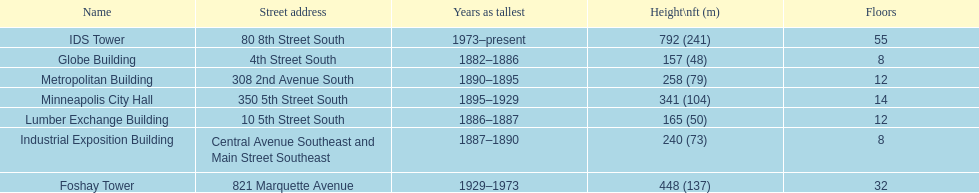How many buildings on the list are taller than 200 feet? 5. 